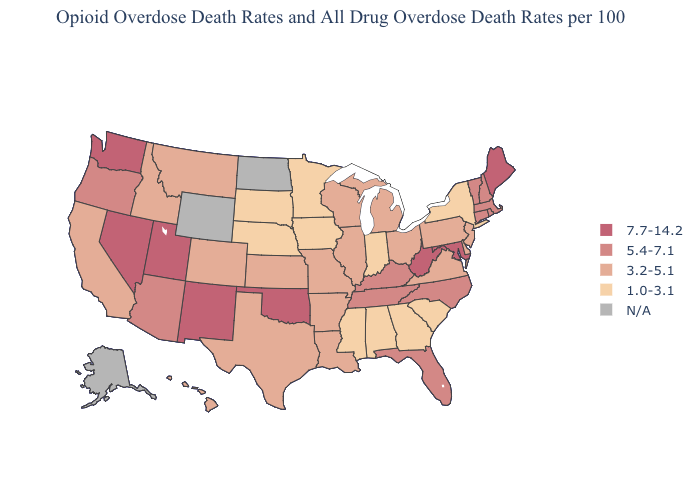Is the legend a continuous bar?
Give a very brief answer. No. Among the states that border New Jersey , which have the highest value?
Answer briefly. Delaware, Pennsylvania. What is the value of Florida?
Be succinct. 5.4-7.1. What is the highest value in the USA?
Concise answer only. 7.7-14.2. Which states have the highest value in the USA?
Write a very short answer. Maine, Maryland, Nevada, New Mexico, Oklahoma, Utah, Washington, West Virginia. What is the value of California?
Short answer required. 3.2-5.1. Which states have the lowest value in the Northeast?
Concise answer only. New York. What is the highest value in the Northeast ?
Be succinct. 7.7-14.2. Which states have the lowest value in the USA?
Short answer required. Alabama, Georgia, Indiana, Iowa, Minnesota, Mississippi, Nebraska, New York, South Carolina, South Dakota. What is the value of West Virginia?
Answer briefly. 7.7-14.2. Among the states that border North Carolina , does Georgia have the highest value?
Concise answer only. No. What is the lowest value in the USA?
Short answer required. 1.0-3.1. Name the states that have a value in the range 3.2-5.1?
Quick response, please. Arkansas, California, Colorado, Delaware, Hawaii, Idaho, Illinois, Kansas, Louisiana, Michigan, Missouri, Montana, New Jersey, Ohio, Pennsylvania, Texas, Virginia, Wisconsin. Name the states that have a value in the range 5.4-7.1?
Short answer required. Arizona, Connecticut, Florida, Kentucky, Massachusetts, New Hampshire, North Carolina, Oregon, Rhode Island, Tennessee, Vermont. Name the states that have a value in the range 3.2-5.1?
Be succinct. Arkansas, California, Colorado, Delaware, Hawaii, Idaho, Illinois, Kansas, Louisiana, Michigan, Missouri, Montana, New Jersey, Ohio, Pennsylvania, Texas, Virginia, Wisconsin. 